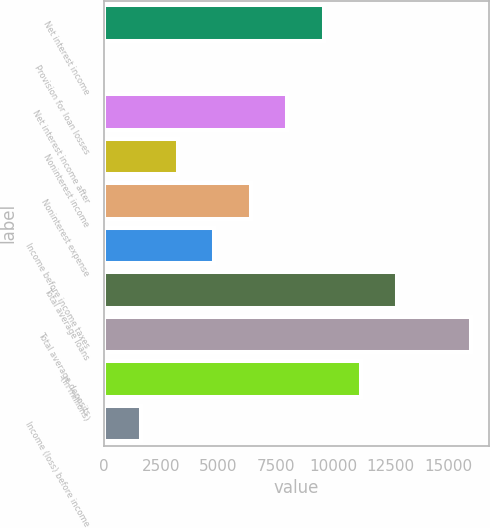Convert chart. <chart><loc_0><loc_0><loc_500><loc_500><bar_chart><fcel>Net interest income<fcel>Provision for loan losses<fcel>Net interest income after<fcel>Noninterest income<fcel>Noninterest expense<fcel>Income before income taxes<fcel>Total average loans<fcel>Total average deposits<fcel>(In millions)<fcel>Income (loss) before income<nl><fcel>9599.2<fcel>19<fcel>8002.5<fcel>3212.4<fcel>6405.8<fcel>4809.1<fcel>12792.6<fcel>15986<fcel>11195.9<fcel>1615.7<nl></chart> 